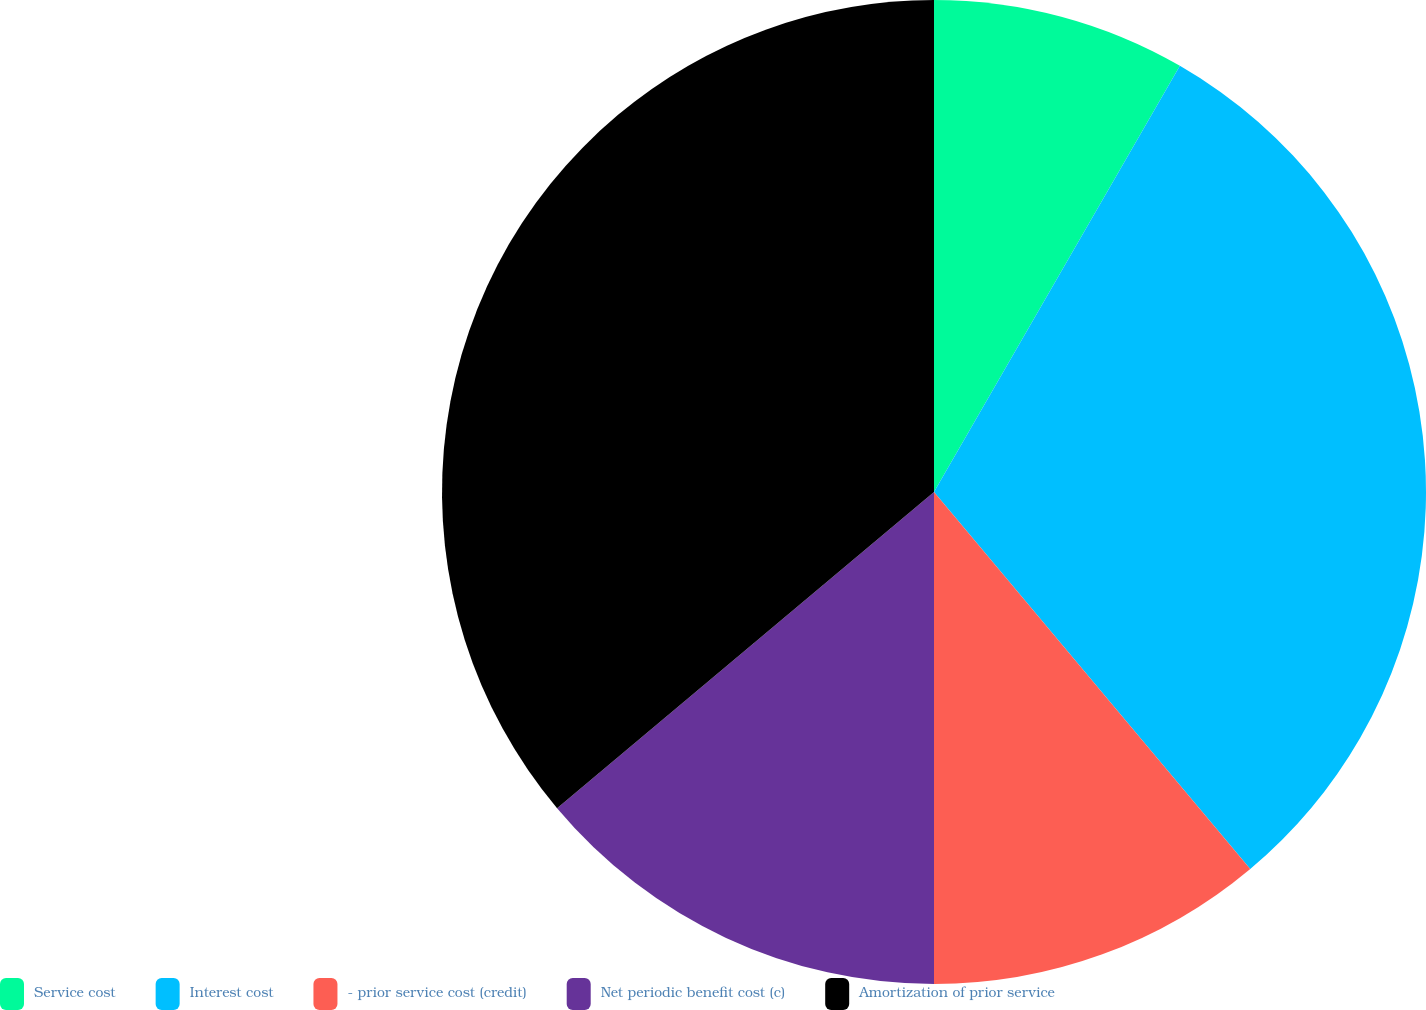Convert chart to OTSL. <chart><loc_0><loc_0><loc_500><loc_500><pie_chart><fcel>Service cost<fcel>Interest cost<fcel>- prior service cost (credit)<fcel>Net periodic benefit cost (c)<fcel>Amortization of prior service<nl><fcel>8.33%<fcel>30.56%<fcel>11.11%<fcel>13.89%<fcel>36.11%<nl></chart> 